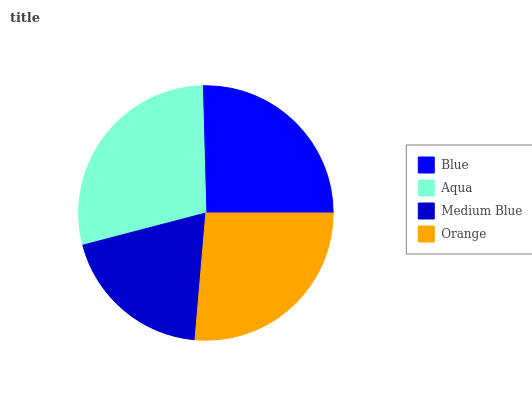Is Medium Blue the minimum?
Answer yes or no. Yes. Is Aqua the maximum?
Answer yes or no. Yes. Is Aqua the minimum?
Answer yes or no. No. Is Medium Blue the maximum?
Answer yes or no. No. Is Aqua greater than Medium Blue?
Answer yes or no. Yes. Is Medium Blue less than Aqua?
Answer yes or no. Yes. Is Medium Blue greater than Aqua?
Answer yes or no. No. Is Aqua less than Medium Blue?
Answer yes or no. No. Is Orange the high median?
Answer yes or no. Yes. Is Blue the low median?
Answer yes or no. Yes. Is Blue the high median?
Answer yes or no. No. Is Orange the low median?
Answer yes or no. No. 